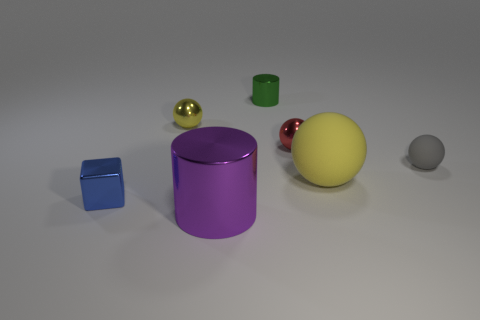Add 1 green things. How many objects exist? 8 Subtract all blue spheres. Subtract all brown cylinders. How many spheres are left? 4 Subtract all cubes. How many objects are left? 6 Subtract all large red rubber spheres. Subtract all tiny yellow spheres. How many objects are left? 6 Add 7 small cylinders. How many small cylinders are left? 8 Add 4 small green objects. How many small green objects exist? 5 Subtract 0 purple balls. How many objects are left? 7 